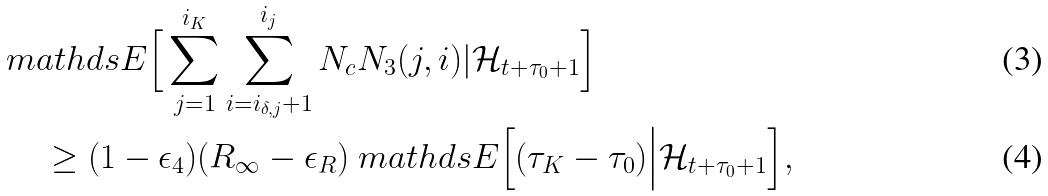<formula> <loc_0><loc_0><loc_500><loc_500>& \ m a t h d s { E } \Big [ \sum _ { j = 1 } ^ { i _ { K } } \sum _ { i = i _ { \delta , j } + 1 } ^ { i _ { j } } N _ { c } N _ { 3 } ( j , i ) | \mathcal { H } _ { t + \tau _ { 0 } + 1 } \Big ] \\ & \quad \ \geq ( 1 - \epsilon _ { 4 } ) ( R _ { \infty } - \epsilon _ { R } ) \ m a t h d s { E } \Big [ ( \tau _ { K } - \tau _ { 0 } ) \Big | \mathcal { H } _ { t + \tau _ { 0 } + 1 } \Big ] ,</formula> 